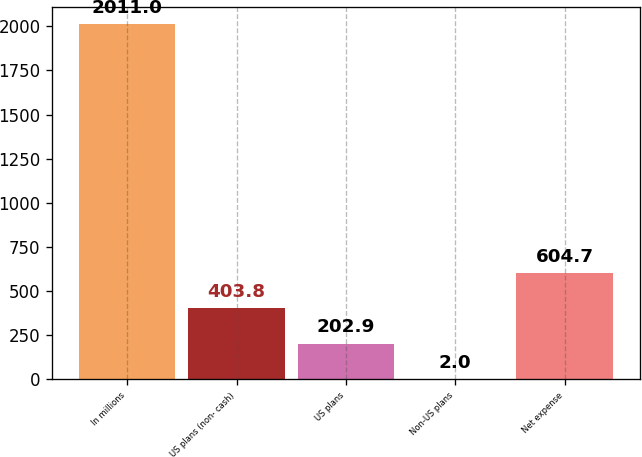<chart> <loc_0><loc_0><loc_500><loc_500><bar_chart><fcel>In millions<fcel>US plans (non- cash)<fcel>US plans<fcel>Non-US plans<fcel>Net expense<nl><fcel>2011<fcel>403.8<fcel>202.9<fcel>2<fcel>604.7<nl></chart> 